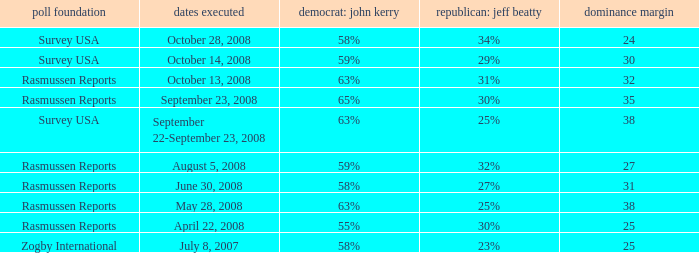What percent is the lead margin of 25 that Republican: Jeff Beatty has according to poll source Rasmussen Reports? 30%. 